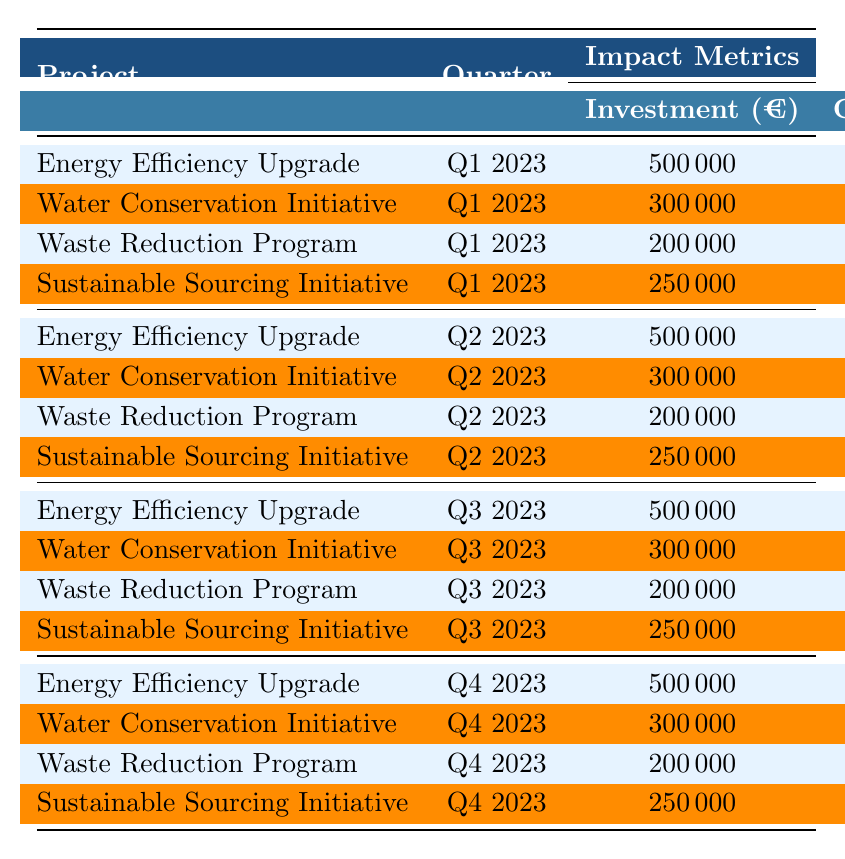What was the carbon emission reduction for the Energy Efficiency Upgrade in Q3 2023? In Q3 2023, the row for the Energy Efficiency Upgrade lists a carbon emission reduction of 170 tons.
Answer: 170 tons Which project had the highest cost savings in Q4 2023? In Q4 2023, the Energy Efficiency Upgrade had the highest cost savings of €90,000 compared to the other projects.
Answer: €90,000 What is the total investment across all projects for Q1 2023? The investments for Q1 2023 are €500,000 (Energy Efficiency Upgrade) + €300,000 (Water Conservation Initiative) + €200,000 (Waste Reduction Program) + €250,000 (Sustainable Sourcing Initiative), totaling €1,250,000.
Answer: €1,250,000 Did the Waste Reduction Program increase its employee engagement from Q1 to Q2 2023? In Q1 2023, the employee engagement for the Waste Reduction Program was 80%, which increased to 82% in Q2 2023, showing an increase.
Answer: Yes What is the average water saved per quarter for the Water Conservation Initiative in 2023? The water saved per quarter is 20,000 m³ (Q1) + 21,000 m³ (Q2) + 22,000 m³ (Q3) + 23,000 m³ (Q4) = 86,000 m³. Then, divide by 4 to get an average of 21,500 m³.
Answer: 21,500 m³ Was there an increase in the percentage of sustainable materials in the Sustainable Sourcing Initiative from Q2 to Q4 2023? In Q2 2023, the percentage of sustainable materials was 42%, which increased to 47% in Q4 2023, indicating an increase.
Answer: Yes Which project consistently had the highest employee engagement throughout the quarters? The Water Conservation Initiative had employee engagement of 90% (Q1), 92% (Q2), 93% (Q3), and 94% (Q4), showing it consistently had the highest engagement.
Answer: Water Conservation Initiative What was the total carbon emission reduction from all projects in Q3 2023? The total carbon emission reductions for Q3 2023 are 170 tons (Energy Efficiency Upgrade) + 0 tons (Water Conservation Initiative) + 0 tons (Waste Reduction Program) + 0 tons (Sustainable Sourcing Initiative), totaling 170 tons.
Answer: 170 tons How much did the investments for the Sustainable Sourcing Initiative change from Q1 to Q4 2023? The investment for the Sustainable Sourcing Initiative remained the same at €250,000 from Q1 to Q4 2023, showing no change.
Answer: No change What was the greatest amount of waste reduced by the Waste Reduction Program and in which quarter did it occur? The Waste Reduction Program reduced the most waste in Q4 2023, with 130 tons reduced, the highest across all quarters.
Answer: 130 tons in Q4 2023 